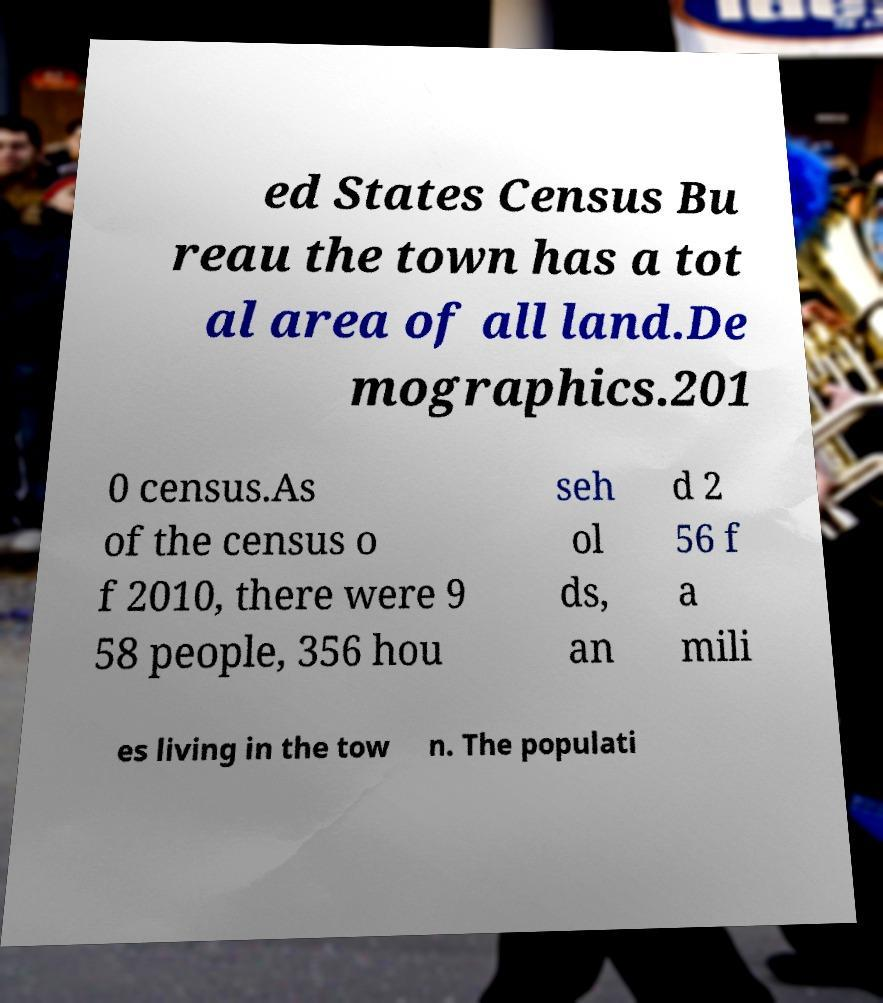There's text embedded in this image that I need extracted. Can you transcribe it verbatim? ed States Census Bu reau the town has a tot al area of all land.De mographics.201 0 census.As of the census o f 2010, there were 9 58 people, 356 hou seh ol ds, an d 2 56 f a mili es living in the tow n. The populati 